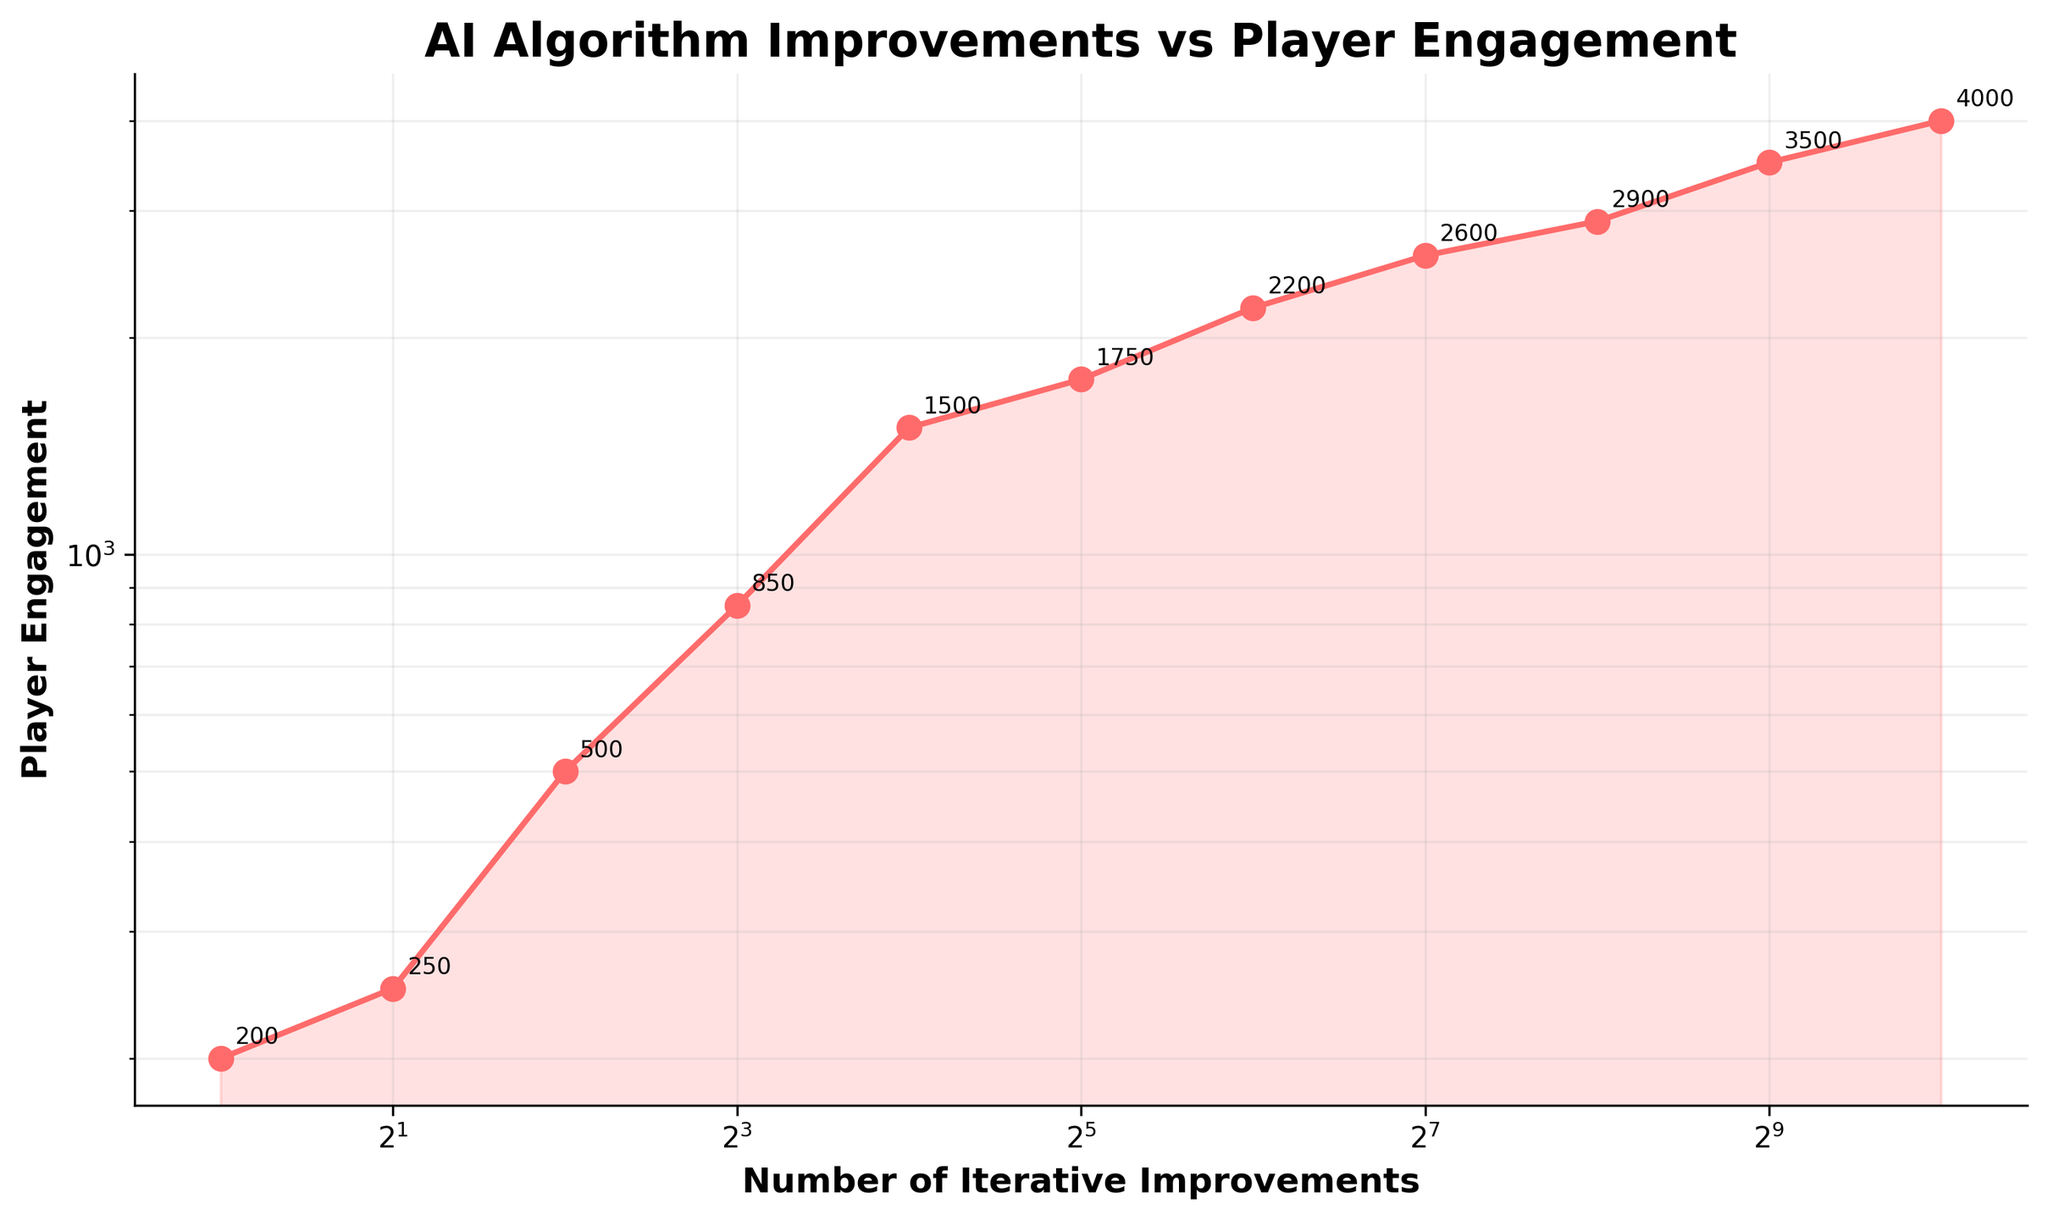What is the title of the plot? The title of the plot is located at the top and it explicitly describes the content of the visual representation. By reading the title in this plot, we understand its focus.
Answer: AI Algorithm Improvements vs Player Engagement What is the value of player engagement at the 8th iteration? To find this value, locate the point corresponding to the 8th iteration on the x-axis and read the associated y-value. It is indicated on the plot and can also be verified by the annotation near the point.
Answer: 850 Which iteration shows the highest player engagement value? To determine this, we compare the y-values of all iterations. The highest y-value represents the maximum player engagement, which can be observed by locating the peak point on the graph.
Answer: 1024 How many data points are plotted on the figure? Counting the number of distinct data points (markers) on the plot gives us the total count of iterations represented on the figure. Each marker corresponds to an iteration.
Answer: 11 What is the color used for the line connecting the data points? Observing the visual appearance of the line, we note its specific color. Its color is consistent throughout, which can be described naturally.
Answer: Red What is the increase in player engagement from the 32nd iteration to the 64th iteration? To find this difference, first locate the player engagement values for iterations 32 and 64. The values are 1750 and 2200 respectively. Subtract the former from the latter to determine the increase. 2200 - 1750 = 450.
Answer: 450 What is the trend of player engagement as the number of iterations increases? By observing the overall pattern of the plotted points, we can describe whether the trend shows an increase, decrease, or something else as the number of iterations rises. The plot and logarithmic scales highlight this trend even more clearly.
Answer: Increasing Between which two consecutive iterations does player engagement experience the largest jump? Compare player engagement values between each pair of consecutive iterations. The largest difference indicates the biggest jump. From 16 to 32: 1750 - 1500 = 250, and from 8 to 16: 1500 - 850 = 650, demonstrating the biggest jump.
Answer: 8 to 16 How does the logarithmic scale on the x-axis affect the visualization of iterative improvements? The logarithmic scale transforms the x-axis into a logarithmic representation, effectively spreading out the iterations exponentially and making it easier to visually interpret growth over a wide range. This type of scale helps display rapid changes in data over time.
Answer: It spreads out the iterations exponentially, aiding in visual interpretation At which iteration does player engagement first exceed 2000? To find the point where player engagement first goes beyond 2000, look at the plotted points and identify the iteration number immediately preceding the point where the y-value exceeds 2000. This can be detected visually on the graph.
Answer: 64 